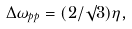Convert formula to latex. <formula><loc_0><loc_0><loc_500><loc_500>\Delta \omega _ { p p } = ( 2 / \surd 3 ) \eta ,</formula> 